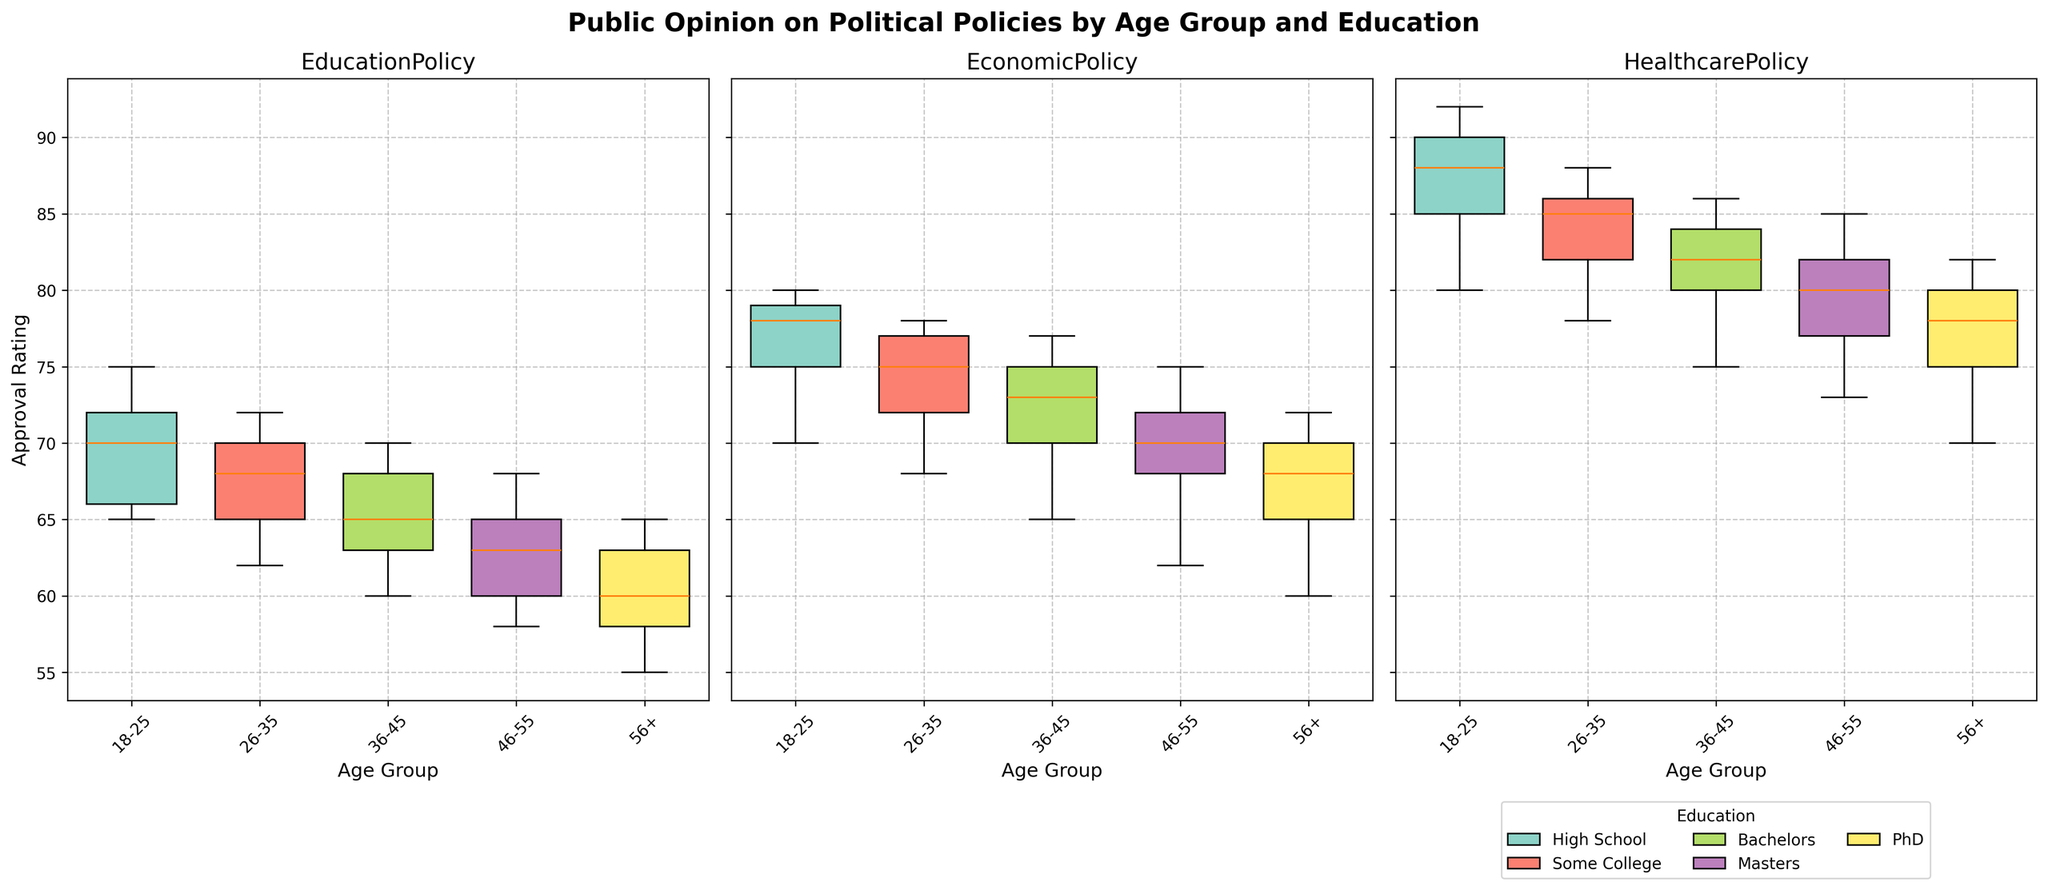What's the title of the chart? The title is displayed at the top of the figure, highlighting the main focus of the plot. The title directly reflects the subject of the figure.
Answer: Public Opinion on Political Policies by Age Group and Education Which policy has the highest approval rating across all age groups and education levels? By observing the height of the box plots, it can be seen that the Healthcare Policy has the highest approval ratings across all age groups and education levels.
Answer: Healthcare Policy How does the approval rating for the Economic Policy change as age increases for a PhD holder? This question requires comparing the Economic Policy box plots for the age groups of PhD holders. We observe that as age increases, the approval rating decreases gradually from 80 in the 18-25 group to 72 in the 56+ group.
Answer: Approval rating decreases Which age group has the widest range of approval ratings for the Education Policy? The range of each box plot represents the difference between the minimum and maximum values; the widest box plot indicates the largest range. Examining the box plots reveals that the 36-45 age group has the widest range for the Education Policy.
Answer: 36-45 What is the median approval rating for the Education Policy among those aged 26-35? The median is represented by the line inside the box plot for the 26-35 age group. The Education Policy's box plot shows that the median for this age group is approximately 65.
Answer: 65 For which age group is the approval rating for the Education Policy the lowest? This involves identifying the lowest point on the box plots for each age group concerning the Education Policy. The 56+ age group has the lowest approval ratings.
Answer: 56+ Compare the approval ratings of the Healthcare Policy between the 18-25 and 56+ age groups. By examining the box plots for the Healthcare Policy of the two groups, it is observed that the 18-25 group has approval ratings ranging from approximately 80 to 92, while the 56+ group ranges from approximately 70 to 82.
Answer: 18-25 group has higher approval ratings Does educational background have a noticeable impact on approval ratings for the Economic Policy? The box plots for all education levels across various age groups must be compared to see if trends are present. Generally, there is a visible trend where higher educational backgrounds correlate with slightly higher approval ratings for the Economic Policy.
Answer: Yes What's the interquartile range (IQR) for the Healthcare Policy for the age group 46-55 holding a Master's degree? The IQR is calculated as the difference between the first and third quartiles of the box plot for the specified group. For the Healthcare Policy, the range is approximately from 72 to 80. So, IQR = 80 - 72 = 8.
Answer: 8 